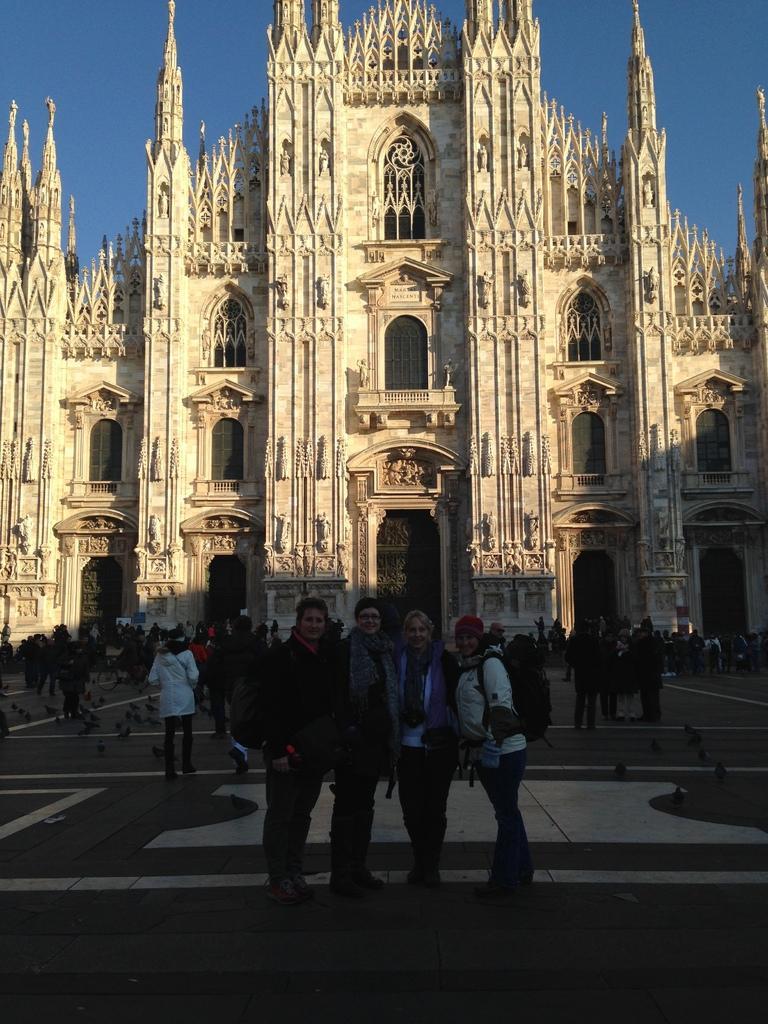In one or two sentences, can you explain what this image depicts? In this image I see number of people and I see many birds over here and I see the path. In the background I see the building and I see the sky. 